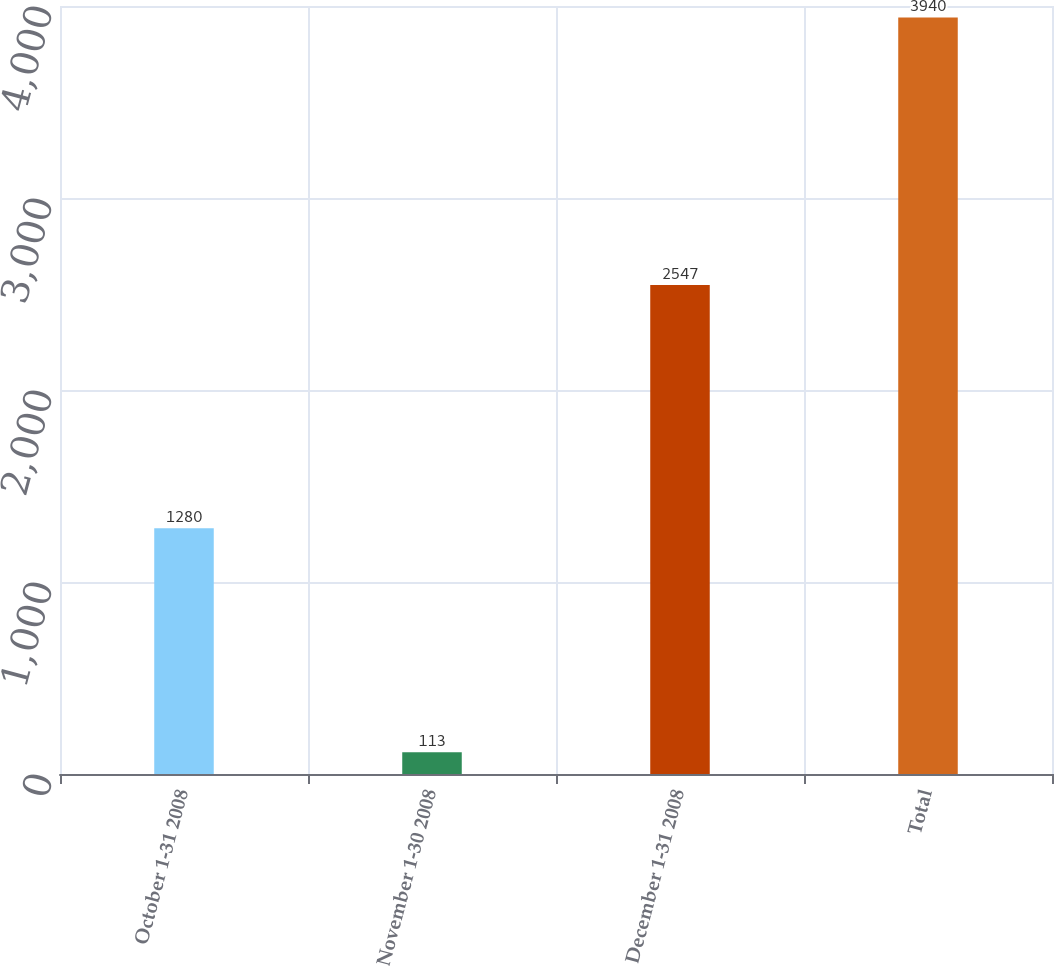<chart> <loc_0><loc_0><loc_500><loc_500><bar_chart><fcel>October 1-31 2008<fcel>November 1-30 2008<fcel>December 1-31 2008<fcel>Total<nl><fcel>1280<fcel>113<fcel>2547<fcel>3940<nl></chart> 